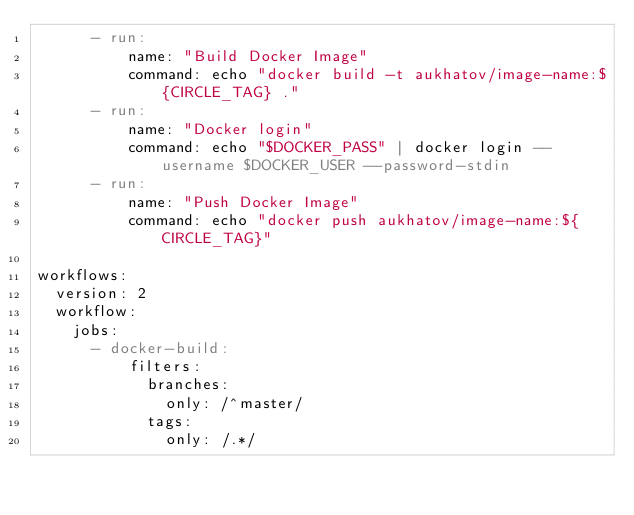Convert code to text. <code><loc_0><loc_0><loc_500><loc_500><_YAML_>      - run:
          name: "Build Docker Image"
          command: echo "docker build -t aukhatov/image-name:${CIRCLE_TAG} ."
      - run:
          name: "Docker login"
          command: echo "$DOCKER_PASS" | docker login --username $DOCKER_USER --password-stdin
      - run:
          name: "Push Docker Image"
          command: echo "docker push aukhatov/image-name:${CIRCLE_TAG}"

workflows:
  version: 2
  workflow:
    jobs:
      - docker-build:
          filters:
            branches:
              only: /^master/
            tags:
              only: /.*/</code> 